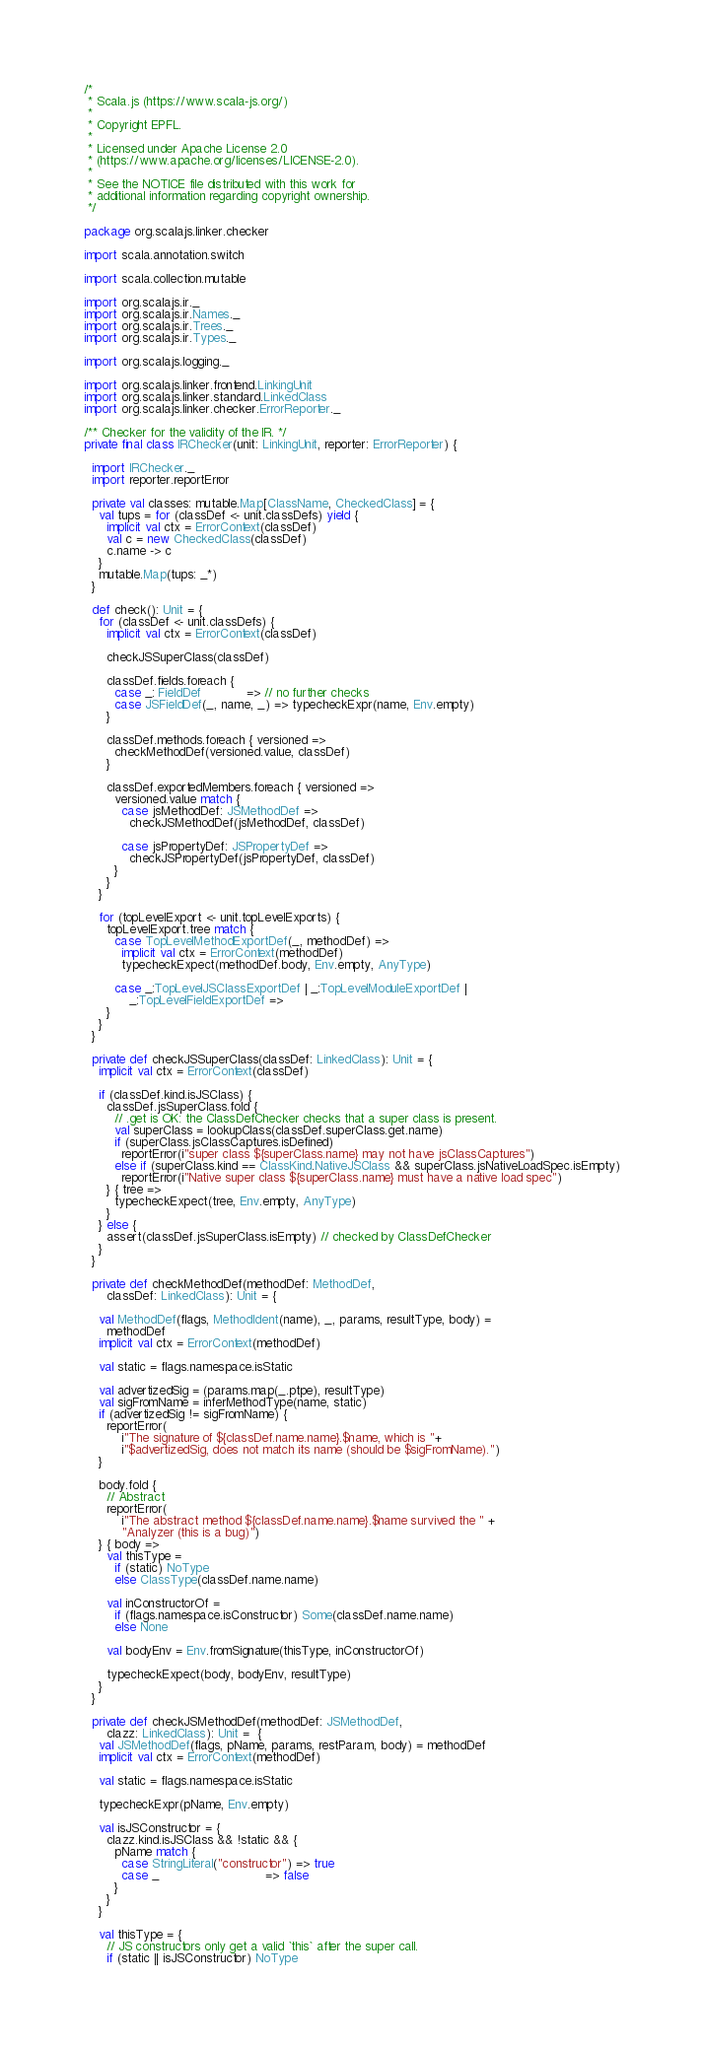Convert code to text. <code><loc_0><loc_0><loc_500><loc_500><_Scala_>/*
 * Scala.js (https://www.scala-js.org/)
 *
 * Copyright EPFL.
 *
 * Licensed under Apache License 2.0
 * (https://www.apache.org/licenses/LICENSE-2.0).
 *
 * See the NOTICE file distributed with this work for
 * additional information regarding copyright ownership.
 */

package org.scalajs.linker.checker

import scala.annotation.switch

import scala.collection.mutable

import org.scalajs.ir._
import org.scalajs.ir.Names._
import org.scalajs.ir.Trees._
import org.scalajs.ir.Types._

import org.scalajs.logging._

import org.scalajs.linker.frontend.LinkingUnit
import org.scalajs.linker.standard.LinkedClass
import org.scalajs.linker.checker.ErrorReporter._

/** Checker for the validity of the IR. */
private final class IRChecker(unit: LinkingUnit, reporter: ErrorReporter) {

  import IRChecker._
  import reporter.reportError

  private val classes: mutable.Map[ClassName, CheckedClass] = {
    val tups = for (classDef <- unit.classDefs) yield {
      implicit val ctx = ErrorContext(classDef)
      val c = new CheckedClass(classDef)
      c.name -> c
    }
    mutable.Map(tups: _*)
  }

  def check(): Unit = {
    for (classDef <- unit.classDefs) {
      implicit val ctx = ErrorContext(classDef)

      checkJSSuperClass(classDef)

      classDef.fields.foreach {
        case _: FieldDef            => // no further checks
        case JSFieldDef(_, name, _) => typecheckExpr(name, Env.empty)
      }

      classDef.methods.foreach { versioned =>
        checkMethodDef(versioned.value, classDef)
      }

      classDef.exportedMembers.foreach { versioned =>
        versioned.value match {
          case jsMethodDef: JSMethodDef =>
            checkJSMethodDef(jsMethodDef, classDef)

          case jsPropertyDef: JSPropertyDef =>
            checkJSPropertyDef(jsPropertyDef, classDef)
        }
      }
    }

    for (topLevelExport <- unit.topLevelExports) {
      topLevelExport.tree match {
        case TopLevelMethodExportDef(_, methodDef) =>
          implicit val ctx = ErrorContext(methodDef)
          typecheckExpect(methodDef.body, Env.empty, AnyType)

        case _:TopLevelJSClassExportDef | _:TopLevelModuleExportDef |
            _:TopLevelFieldExportDef =>
      }
    }
  }

  private def checkJSSuperClass(classDef: LinkedClass): Unit = {
    implicit val ctx = ErrorContext(classDef)

    if (classDef.kind.isJSClass) {
      classDef.jsSuperClass.fold {
        // .get is OK: the ClassDefChecker checks that a super class is present.
        val superClass = lookupClass(classDef.superClass.get.name)
        if (superClass.jsClassCaptures.isDefined)
          reportError(i"super class ${superClass.name} may not have jsClassCaptures")
        else if (superClass.kind == ClassKind.NativeJSClass && superClass.jsNativeLoadSpec.isEmpty)
          reportError(i"Native super class ${superClass.name} must have a native load spec")
      } { tree =>
        typecheckExpect(tree, Env.empty, AnyType)
      }
    } else {
      assert(classDef.jsSuperClass.isEmpty) // checked by ClassDefChecker
    }
  }

  private def checkMethodDef(methodDef: MethodDef,
      classDef: LinkedClass): Unit = {

    val MethodDef(flags, MethodIdent(name), _, params, resultType, body) =
      methodDef
    implicit val ctx = ErrorContext(methodDef)

    val static = flags.namespace.isStatic

    val advertizedSig = (params.map(_.ptpe), resultType)
    val sigFromName = inferMethodType(name, static)
    if (advertizedSig != sigFromName) {
      reportError(
          i"The signature of ${classDef.name.name}.$name, which is "+
          i"$advertizedSig, does not match its name (should be $sigFromName).")
    }

    body.fold {
      // Abstract
      reportError(
          i"The abstract method ${classDef.name.name}.$name survived the " +
          "Analyzer (this is a bug)")
    } { body =>
      val thisType =
        if (static) NoType
        else ClassType(classDef.name.name)

      val inConstructorOf =
        if (flags.namespace.isConstructor) Some(classDef.name.name)
        else None

      val bodyEnv = Env.fromSignature(thisType, inConstructorOf)

      typecheckExpect(body, bodyEnv, resultType)
    }
  }

  private def checkJSMethodDef(methodDef: JSMethodDef,
      clazz: LinkedClass): Unit =  {
    val JSMethodDef(flags, pName, params, restParam, body) = methodDef
    implicit val ctx = ErrorContext(methodDef)

    val static = flags.namespace.isStatic

    typecheckExpr(pName, Env.empty)

    val isJSConstructor = {
      clazz.kind.isJSClass && !static && {
        pName match {
          case StringLiteral("constructor") => true
          case _                            => false
        }
      }
    }

    val thisType = {
      // JS constructors only get a valid `this` after the super call.
      if (static || isJSConstructor) NoType</code> 